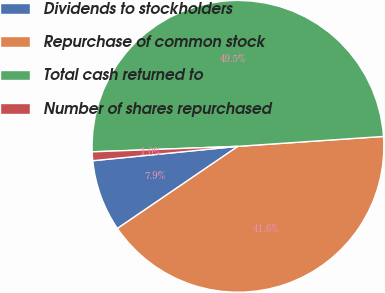Convert chart. <chart><loc_0><loc_0><loc_500><loc_500><pie_chart><fcel>Dividends to stockholders<fcel>Repurchase of common stock<fcel>Total cash returned to<fcel>Number of shares repurchased<nl><fcel>7.95%<fcel>41.56%<fcel>49.52%<fcel>0.97%<nl></chart> 